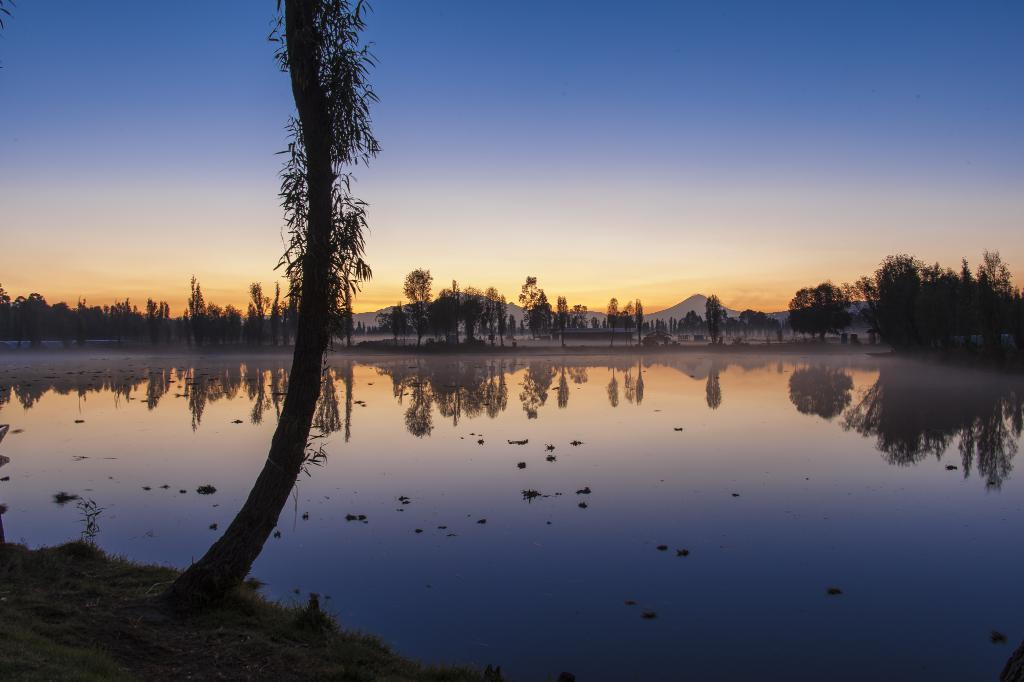What type of natural feature is present in the image? There is a lake in the image. What other natural elements can be seen in the image? There are trees in the image. What can be seen in the distance in the image? There are hills visible in the background of the image. What is visible above the hills in the image? The sky is visible in the background of the image. Where are the firemen located in the image? There are no firemen present in the image. What type of ornament is hanging from the trees in the image? There are no ornaments hanging from the trees in the image; only trees and a lake are visible. 